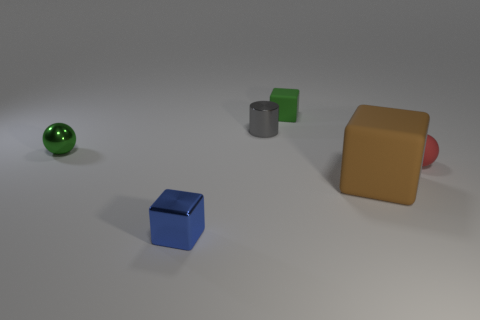There is a small object that is the same color as the metal sphere; what material is it?
Provide a short and direct response. Rubber. Are there fewer objects behind the rubber sphere than gray shiny cylinders that are to the right of the large block?
Your answer should be compact. No. There is another block that is made of the same material as the large cube; what is its color?
Ensure brevity in your answer.  Green. The tiny matte thing behind the small thing that is on the right side of the brown matte cube is what color?
Your response must be concise. Green. Are there any shiny things of the same color as the large matte object?
Provide a succinct answer. No. The green rubber object that is the same size as the red ball is what shape?
Make the answer very short. Cube. What number of big brown cubes are to the right of the blue shiny block right of the small green shiny sphere?
Your answer should be compact. 1. Is the color of the small cylinder the same as the metal sphere?
Make the answer very short. No. What number of other things are there of the same material as the green cube
Your answer should be very brief. 2. There is a matte thing that is behind the tiny matte thing in front of the small gray metallic cylinder; what is its shape?
Your response must be concise. Cube. 